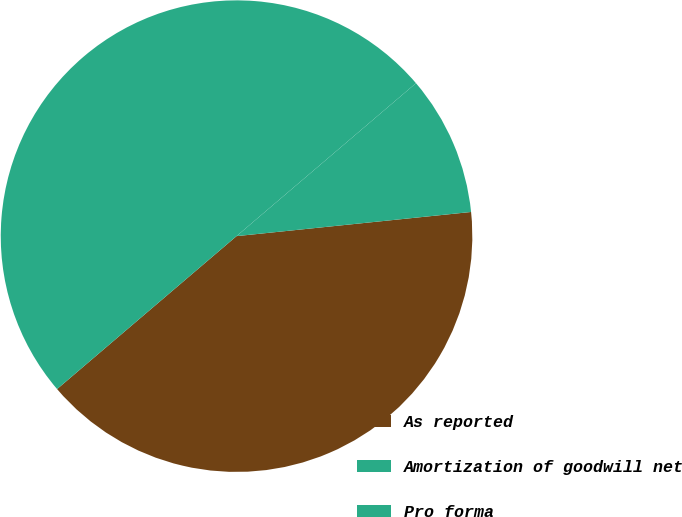<chart> <loc_0><loc_0><loc_500><loc_500><pie_chart><fcel>As reported<fcel>Amortization of goodwill net<fcel>Pro forma<nl><fcel>40.4%<fcel>9.6%<fcel>50.0%<nl></chart> 